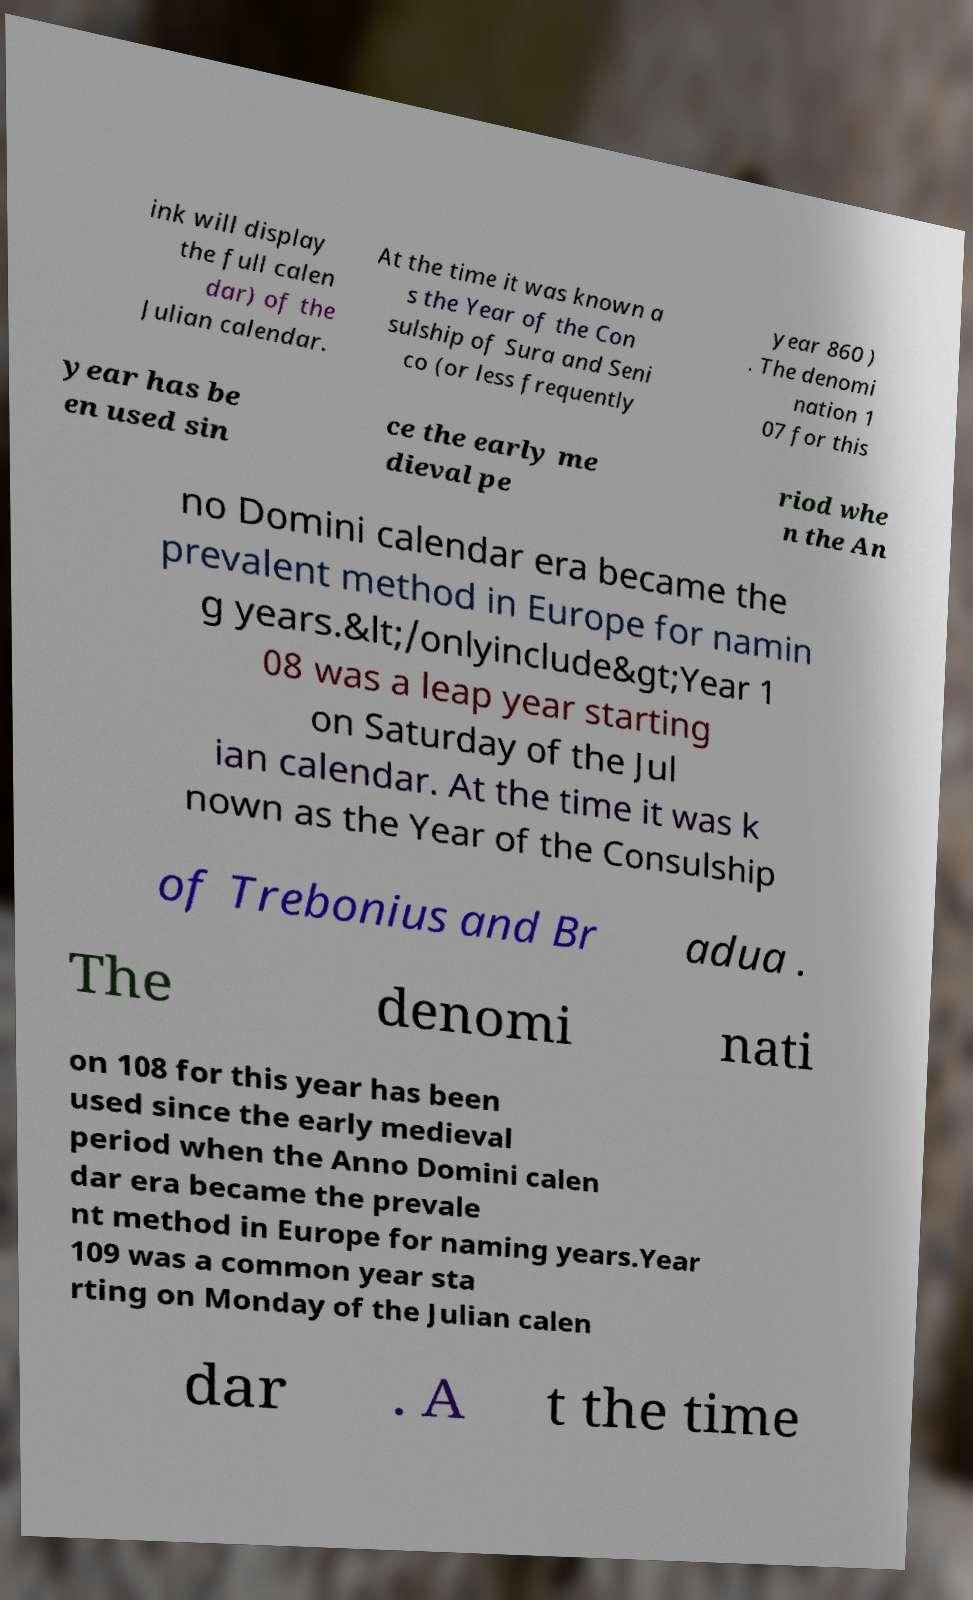Please identify and transcribe the text found in this image. ink will display the full calen dar) of the Julian calendar. At the time it was known a s the Year of the Con sulship of Sura and Seni co (or less frequently year 860 ) . The denomi nation 1 07 for this year has be en used sin ce the early me dieval pe riod whe n the An no Domini calendar era became the prevalent method in Europe for namin g years.&lt;/onlyinclude&gt;Year 1 08 was a leap year starting on Saturday of the Jul ian calendar. At the time it was k nown as the Year of the Consulship of Trebonius and Br adua . The denomi nati on 108 for this year has been used since the early medieval period when the Anno Domini calen dar era became the prevale nt method in Europe for naming years.Year 109 was a common year sta rting on Monday of the Julian calen dar . A t the time 